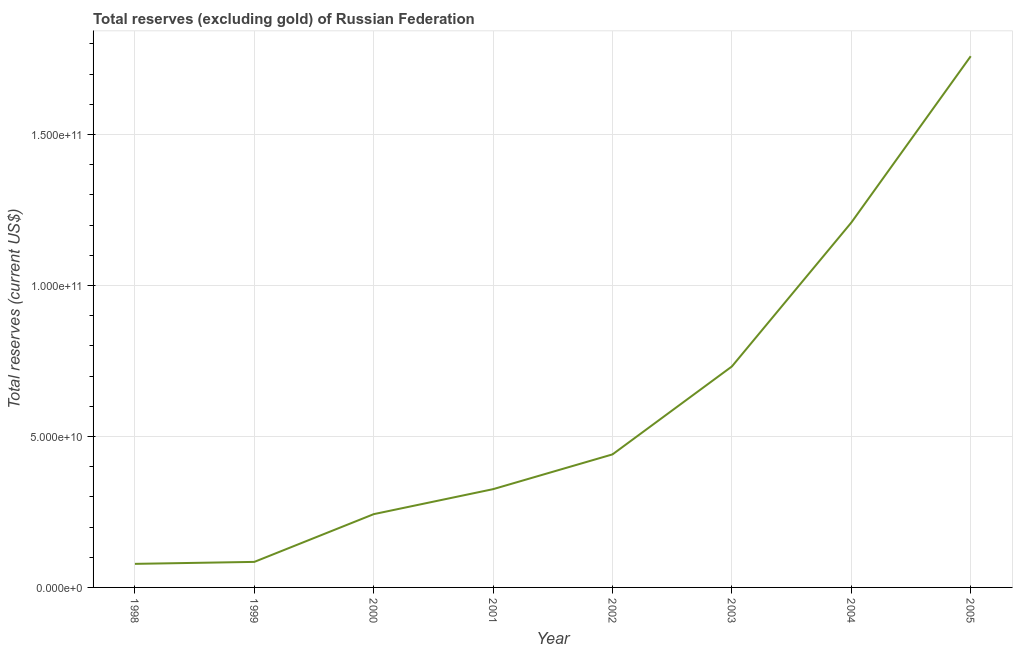What is the total reserves (excluding gold) in 2000?
Keep it short and to the point. 2.43e+1. Across all years, what is the maximum total reserves (excluding gold)?
Your response must be concise. 1.76e+11. Across all years, what is the minimum total reserves (excluding gold)?
Offer a terse response. 7.80e+09. In which year was the total reserves (excluding gold) maximum?
Ensure brevity in your answer.  2005. In which year was the total reserves (excluding gold) minimum?
Your answer should be compact. 1998. What is the sum of the total reserves (excluding gold)?
Offer a terse response. 4.87e+11. What is the difference between the total reserves (excluding gold) in 1998 and 2002?
Give a very brief answer. -3.63e+1. What is the average total reserves (excluding gold) per year?
Ensure brevity in your answer.  6.09e+1. What is the median total reserves (excluding gold)?
Ensure brevity in your answer.  3.83e+1. What is the ratio of the total reserves (excluding gold) in 2000 to that in 2002?
Your answer should be compact. 0.55. Is the total reserves (excluding gold) in 2001 less than that in 2005?
Offer a terse response. Yes. What is the difference between the highest and the second highest total reserves (excluding gold)?
Provide a succinct answer. 5.51e+1. What is the difference between the highest and the lowest total reserves (excluding gold)?
Your response must be concise. 1.68e+11. In how many years, is the total reserves (excluding gold) greater than the average total reserves (excluding gold) taken over all years?
Offer a very short reply. 3. Are the values on the major ticks of Y-axis written in scientific E-notation?
Give a very brief answer. Yes. What is the title of the graph?
Your answer should be compact. Total reserves (excluding gold) of Russian Federation. What is the label or title of the X-axis?
Your response must be concise. Year. What is the label or title of the Y-axis?
Ensure brevity in your answer.  Total reserves (current US$). What is the Total reserves (current US$) of 1998?
Your response must be concise. 7.80e+09. What is the Total reserves (current US$) of 1999?
Keep it short and to the point. 8.46e+09. What is the Total reserves (current US$) of 2000?
Keep it short and to the point. 2.43e+1. What is the Total reserves (current US$) in 2001?
Keep it short and to the point. 3.25e+1. What is the Total reserves (current US$) of 2002?
Offer a very short reply. 4.41e+1. What is the Total reserves (current US$) of 2003?
Offer a very short reply. 7.32e+1. What is the Total reserves (current US$) of 2004?
Give a very brief answer. 1.21e+11. What is the Total reserves (current US$) of 2005?
Make the answer very short. 1.76e+11. What is the difference between the Total reserves (current US$) in 1998 and 1999?
Your answer should be compact. -6.56e+08. What is the difference between the Total reserves (current US$) in 1998 and 2000?
Make the answer very short. -1.65e+1. What is the difference between the Total reserves (current US$) in 1998 and 2001?
Provide a short and direct response. -2.47e+1. What is the difference between the Total reserves (current US$) in 1998 and 2002?
Provide a succinct answer. -3.63e+1. What is the difference between the Total reserves (current US$) in 1998 and 2003?
Provide a short and direct response. -6.54e+1. What is the difference between the Total reserves (current US$) in 1998 and 2004?
Offer a very short reply. -1.13e+11. What is the difference between the Total reserves (current US$) in 1998 and 2005?
Offer a terse response. -1.68e+11. What is the difference between the Total reserves (current US$) in 1999 and 2000?
Keep it short and to the point. -1.58e+1. What is the difference between the Total reserves (current US$) in 1999 and 2001?
Provide a short and direct response. -2.41e+1. What is the difference between the Total reserves (current US$) in 1999 and 2002?
Offer a very short reply. -3.56e+1. What is the difference between the Total reserves (current US$) in 1999 and 2003?
Provide a short and direct response. -6.47e+1. What is the difference between the Total reserves (current US$) in 1999 and 2004?
Your answer should be compact. -1.12e+11. What is the difference between the Total reserves (current US$) in 1999 and 2005?
Your answer should be compact. -1.67e+11. What is the difference between the Total reserves (current US$) in 2000 and 2001?
Make the answer very short. -8.28e+09. What is the difference between the Total reserves (current US$) in 2000 and 2002?
Your answer should be compact. -1.98e+1. What is the difference between the Total reserves (current US$) in 2000 and 2003?
Offer a very short reply. -4.89e+1. What is the difference between the Total reserves (current US$) in 2000 and 2004?
Your response must be concise. -9.65e+1. What is the difference between the Total reserves (current US$) in 2000 and 2005?
Keep it short and to the point. -1.52e+11. What is the difference between the Total reserves (current US$) in 2001 and 2002?
Give a very brief answer. -1.15e+1. What is the difference between the Total reserves (current US$) in 2001 and 2003?
Offer a very short reply. -4.06e+1. What is the difference between the Total reserves (current US$) in 2001 and 2004?
Give a very brief answer. -8.83e+1. What is the difference between the Total reserves (current US$) in 2001 and 2005?
Ensure brevity in your answer.  -1.43e+11. What is the difference between the Total reserves (current US$) in 2002 and 2003?
Your answer should be compact. -2.91e+1. What is the difference between the Total reserves (current US$) in 2002 and 2004?
Make the answer very short. -7.68e+1. What is the difference between the Total reserves (current US$) in 2002 and 2005?
Offer a terse response. -1.32e+11. What is the difference between the Total reserves (current US$) in 2003 and 2004?
Keep it short and to the point. -4.76e+1. What is the difference between the Total reserves (current US$) in 2003 and 2005?
Keep it short and to the point. -1.03e+11. What is the difference between the Total reserves (current US$) in 2004 and 2005?
Provide a succinct answer. -5.51e+1. What is the ratio of the Total reserves (current US$) in 1998 to that in 1999?
Make the answer very short. 0.92. What is the ratio of the Total reserves (current US$) in 1998 to that in 2000?
Offer a very short reply. 0.32. What is the ratio of the Total reserves (current US$) in 1998 to that in 2001?
Your answer should be compact. 0.24. What is the ratio of the Total reserves (current US$) in 1998 to that in 2002?
Make the answer very short. 0.18. What is the ratio of the Total reserves (current US$) in 1998 to that in 2003?
Ensure brevity in your answer.  0.11. What is the ratio of the Total reserves (current US$) in 1998 to that in 2004?
Your answer should be very brief. 0.07. What is the ratio of the Total reserves (current US$) in 1998 to that in 2005?
Ensure brevity in your answer.  0.04. What is the ratio of the Total reserves (current US$) in 1999 to that in 2000?
Provide a succinct answer. 0.35. What is the ratio of the Total reserves (current US$) in 1999 to that in 2001?
Provide a short and direct response. 0.26. What is the ratio of the Total reserves (current US$) in 1999 to that in 2002?
Your response must be concise. 0.19. What is the ratio of the Total reserves (current US$) in 1999 to that in 2003?
Ensure brevity in your answer.  0.12. What is the ratio of the Total reserves (current US$) in 1999 to that in 2004?
Your answer should be very brief. 0.07. What is the ratio of the Total reserves (current US$) in 1999 to that in 2005?
Offer a terse response. 0.05. What is the ratio of the Total reserves (current US$) in 2000 to that in 2001?
Your answer should be compact. 0.75. What is the ratio of the Total reserves (current US$) in 2000 to that in 2002?
Provide a short and direct response. 0.55. What is the ratio of the Total reserves (current US$) in 2000 to that in 2003?
Your answer should be compact. 0.33. What is the ratio of the Total reserves (current US$) in 2000 to that in 2004?
Give a very brief answer. 0.2. What is the ratio of the Total reserves (current US$) in 2000 to that in 2005?
Provide a succinct answer. 0.14. What is the ratio of the Total reserves (current US$) in 2001 to that in 2002?
Offer a terse response. 0.74. What is the ratio of the Total reserves (current US$) in 2001 to that in 2003?
Your response must be concise. 0.45. What is the ratio of the Total reserves (current US$) in 2001 to that in 2004?
Keep it short and to the point. 0.27. What is the ratio of the Total reserves (current US$) in 2001 to that in 2005?
Your answer should be compact. 0.18. What is the ratio of the Total reserves (current US$) in 2002 to that in 2003?
Keep it short and to the point. 0.6. What is the ratio of the Total reserves (current US$) in 2002 to that in 2004?
Your response must be concise. 0.36. What is the ratio of the Total reserves (current US$) in 2002 to that in 2005?
Provide a succinct answer. 0.25. What is the ratio of the Total reserves (current US$) in 2003 to that in 2004?
Your response must be concise. 0.61. What is the ratio of the Total reserves (current US$) in 2003 to that in 2005?
Offer a terse response. 0.42. What is the ratio of the Total reserves (current US$) in 2004 to that in 2005?
Your response must be concise. 0.69. 